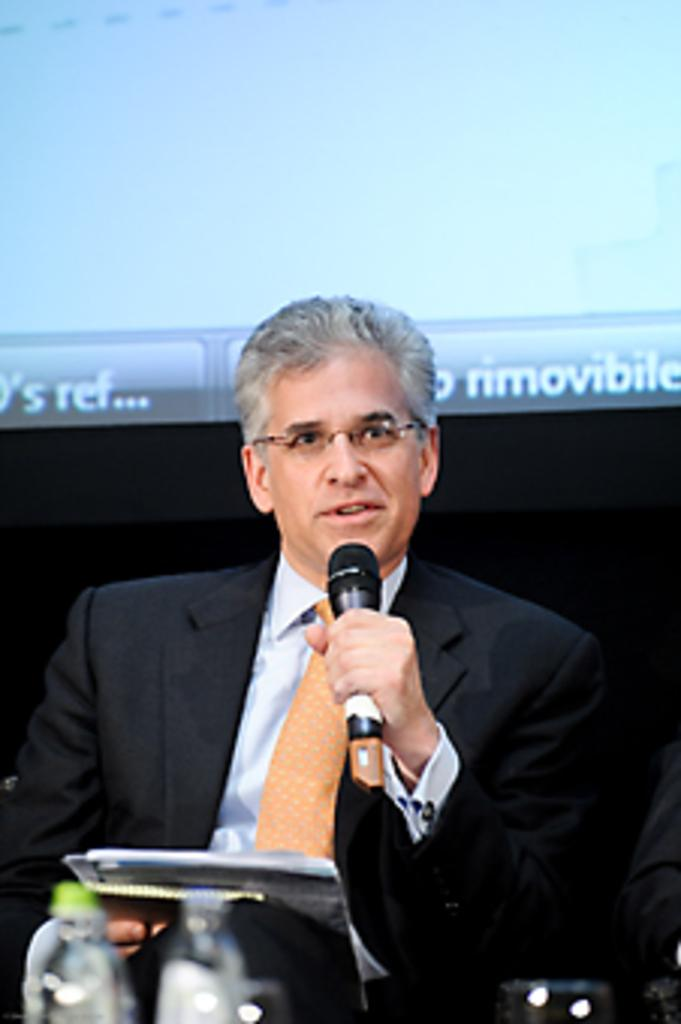What is the main subject of the image? The main subject of the image is a man. What is the man doing in the image? The man is sitting in the image. What is the man holding in his hand? The man is holding a microphone in his hand. Are there any other objects in the man's hand besides the microphone? Yes, there are other objects in the man's hand. Is the man sinking in quicksand in the image? No, there is no quicksand present in the image, and the man is sitting on a surface. What type of crime is the man committing in the image? There is no crime being committed in the image; the man is simply sitting and holding a microphone. 